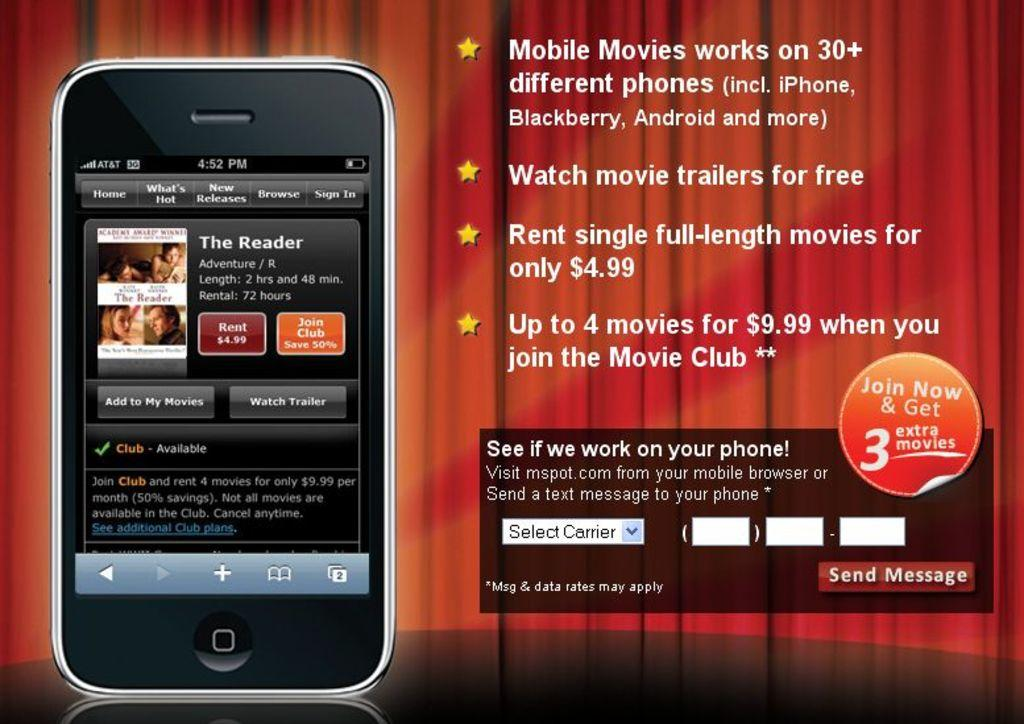<image>
Provide a brief description of the given image. an ad for Mobile Movies and all the info about it 